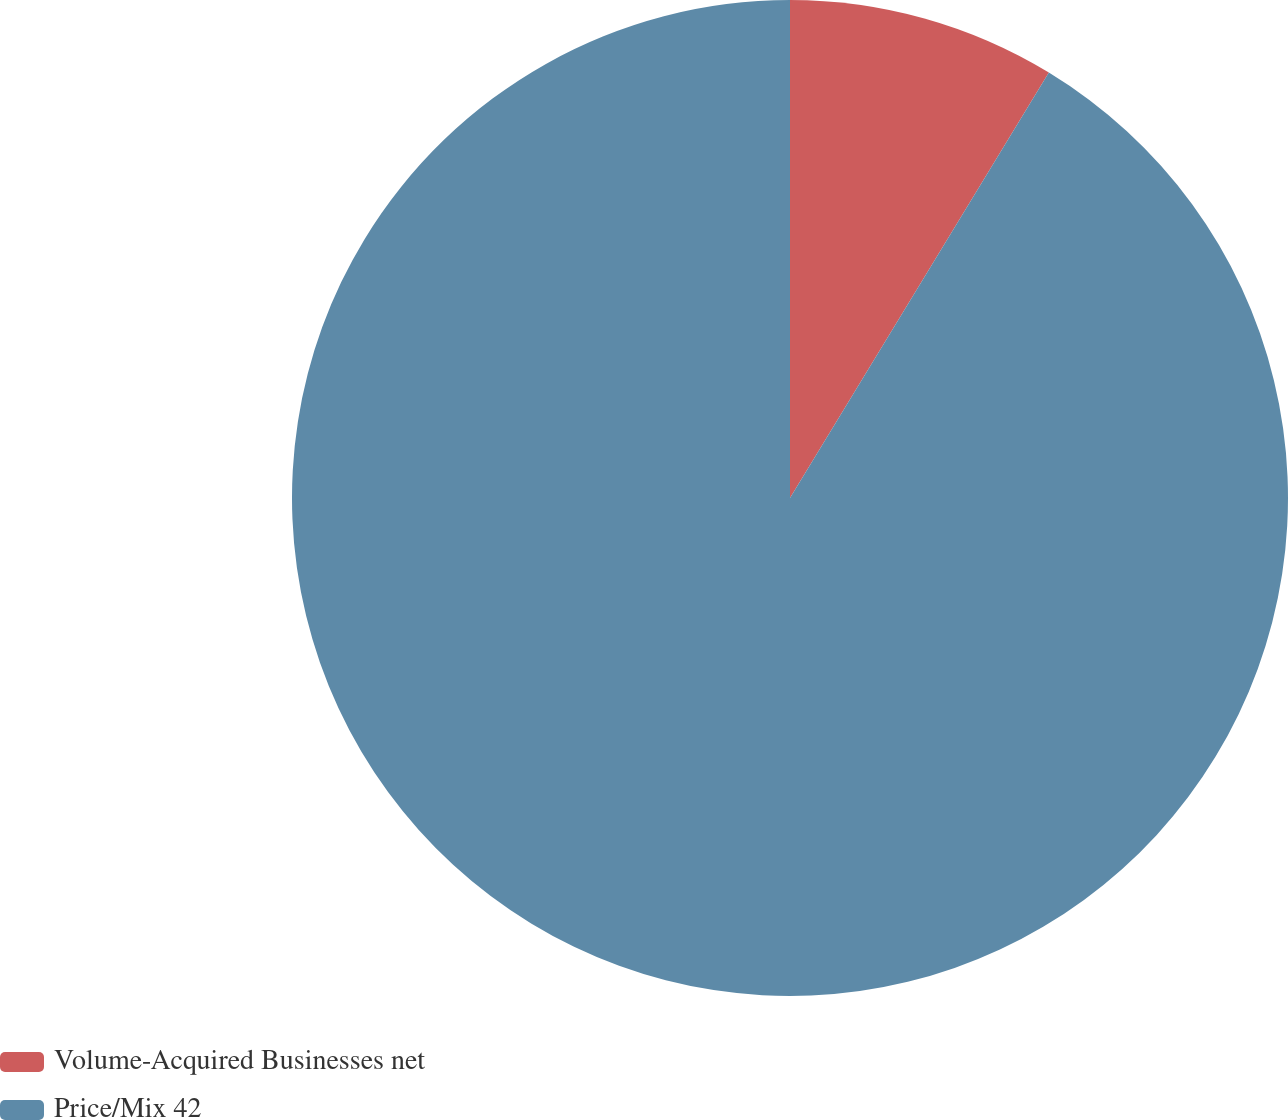Convert chart. <chart><loc_0><loc_0><loc_500><loc_500><pie_chart><fcel>Volume-Acquired Businesses net<fcel>Price/Mix 42<nl><fcel>8.7%<fcel>91.3%<nl></chart> 